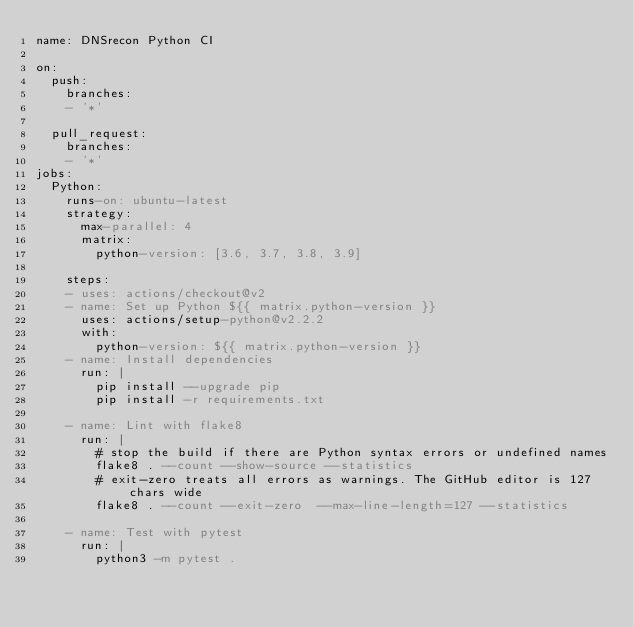<code> <loc_0><loc_0><loc_500><loc_500><_YAML_>name: DNSrecon Python CI

on:
  push:
    branches:
    - '*'

  pull_request:
    branches:
    - '*'
jobs:
  Python:
    runs-on: ubuntu-latest
    strategy:
      max-parallel: 4
      matrix:
        python-version: [3.6, 3.7, 3.8, 3.9]

    steps:
    - uses: actions/checkout@v2
    - name: Set up Python ${{ matrix.python-version }}
      uses: actions/setup-python@v2.2.2
      with:
        python-version: ${{ matrix.python-version }}
    - name: Install dependencies
      run: |
        pip install --upgrade pip
        pip install -r requirements.txt

    - name: Lint with flake8
      run: |
        # stop the build if there are Python syntax errors or undefined names
        flake8 . --count --show-source --statistics
        # exit-zero treats all errors as warnings. The GitHub editor is 127 chars wide
        flake8 . --count --exit-zero  --max-line-length=127 --statistics
    
    - name: Test with pytest
      run: |
        python3 -m pytest .
</code> 